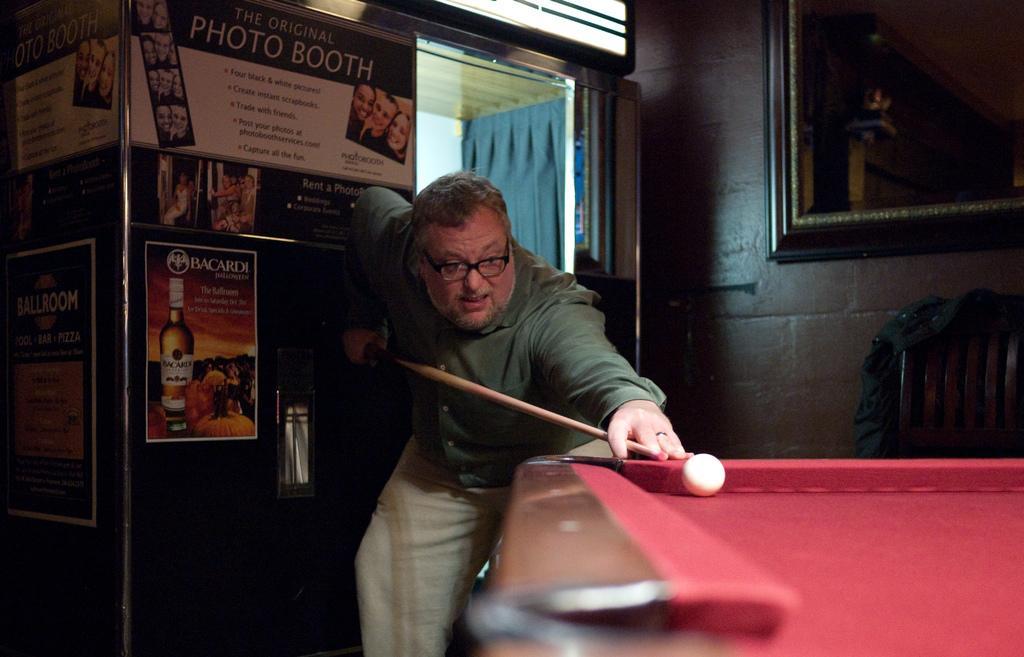Can you describe this image briefly? In this image I can see a person playing the game snooker. He is in front of the Snooker board and holding the stick. He is wearing a green color shirt. There is a ball on the board. In the back there are many papers attached and a frame to the wall. I can see a curtain. 